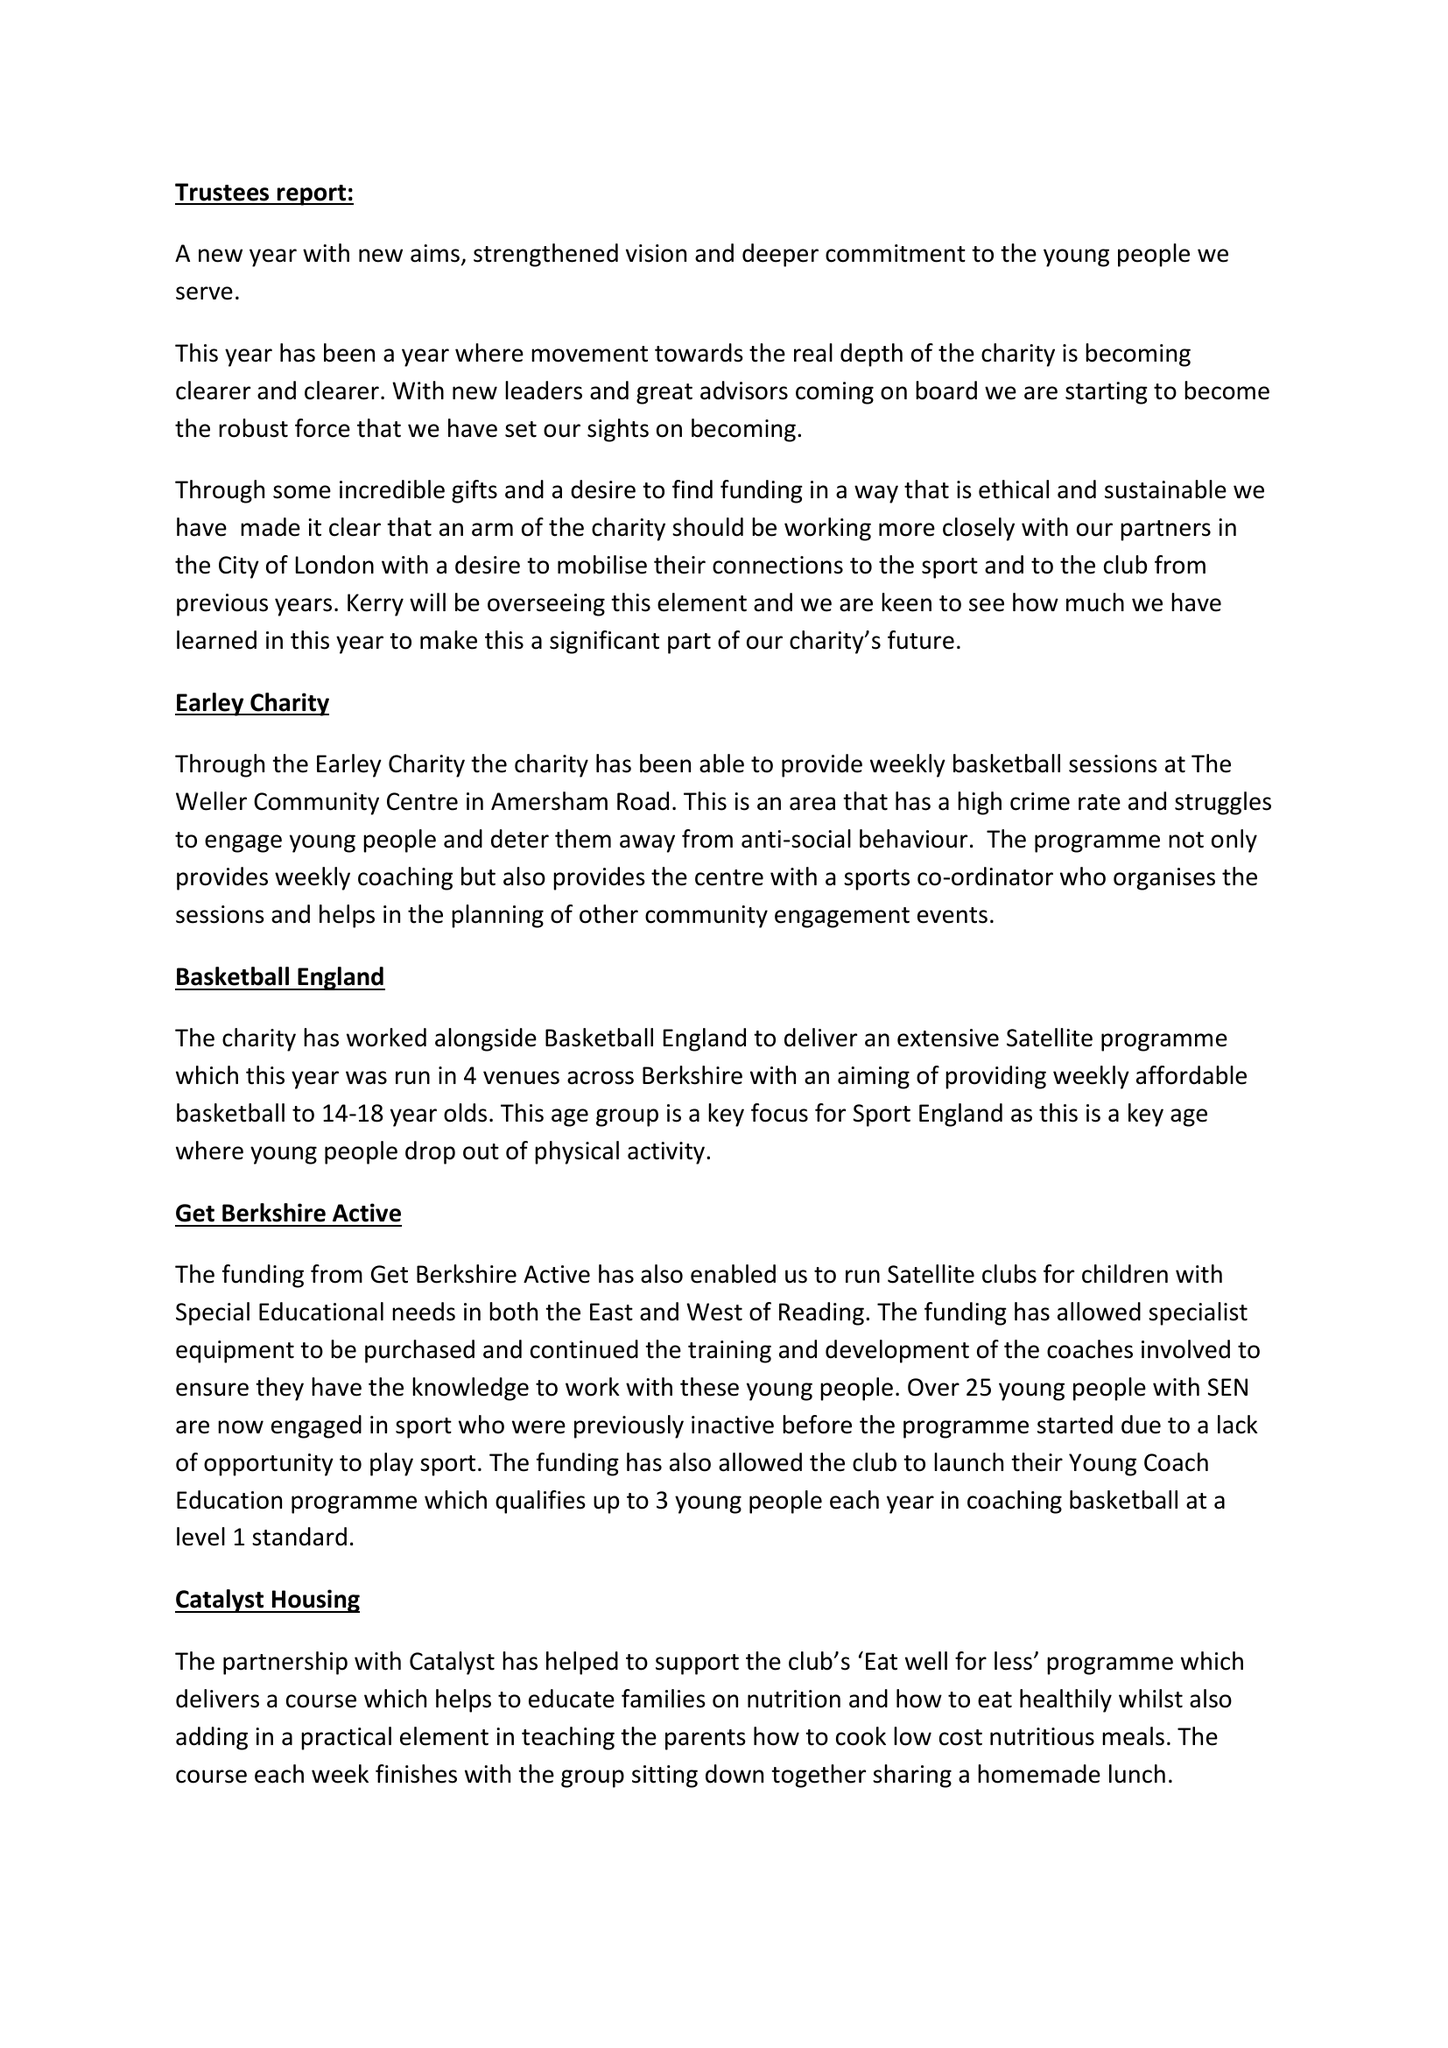What is the value for the address__street_line?
Answer the question using a single word or phrase. 39 FINCH ROAD 